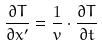<formula> <loc_0><loc_0><loc_500><loc_500>\frac { \partial T } { \partial x ^ { \prime } } = \frac { 1 } { v } \cdot \frac { \partial T } { \partial t }</formula> 